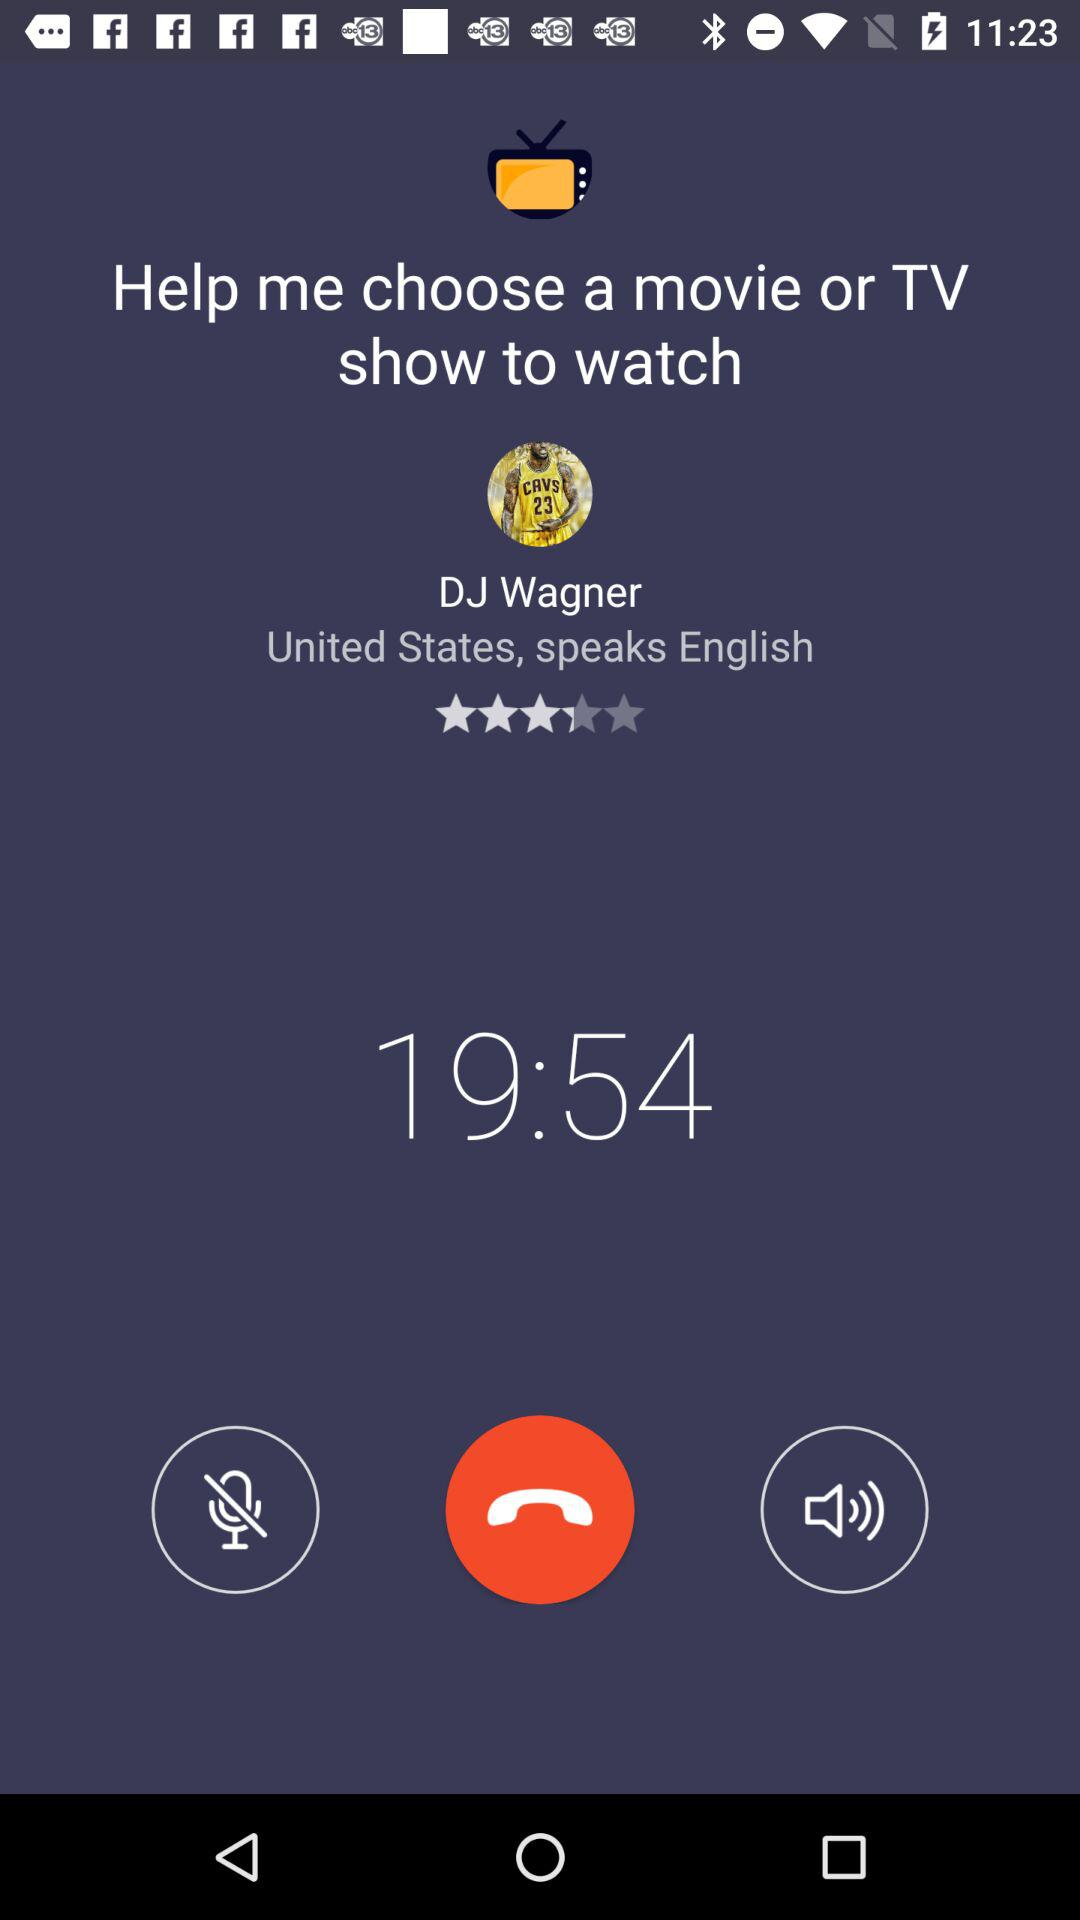What is the mentioned time? The mentioned time is 19:54. 